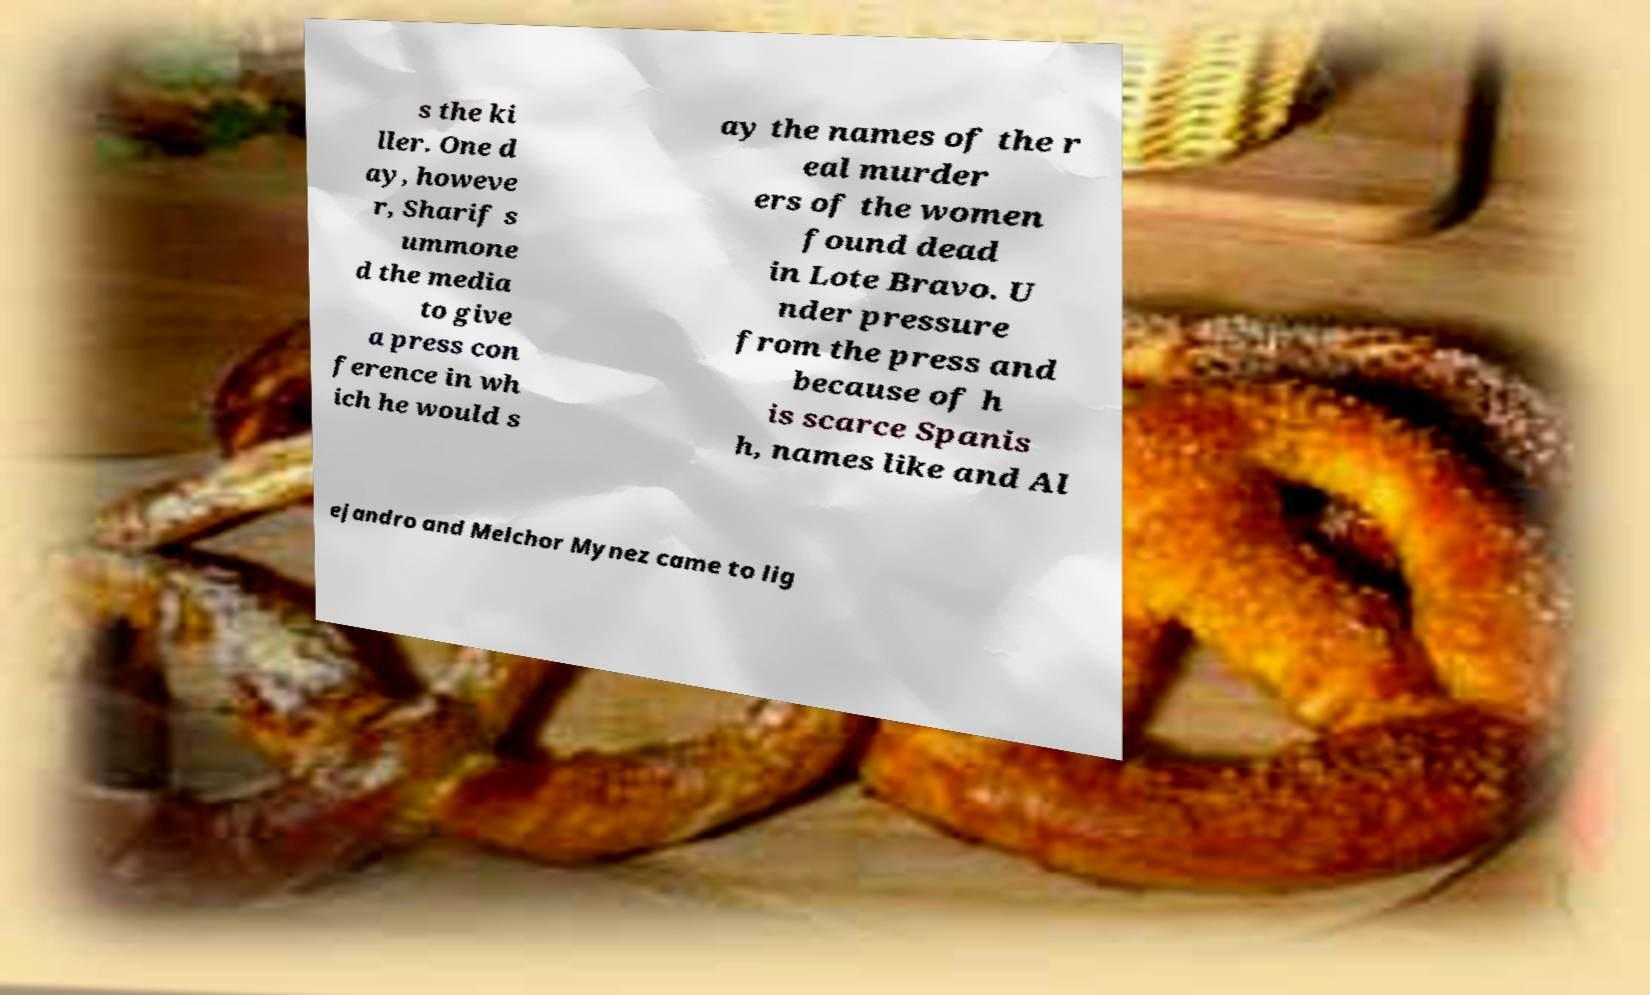Could you extract and type out the text from this image? s the ki ller. One d ay, howeve r, Sharif s ummone d the media to give a press con ference in wh ich he would s ay the names of the r eal murder ers of the women found dead in Lote Bravo. U nder pressure from the press and because of h is scarce Spanis h, names like and Al ejandro and Melchor Mynez came to lig 